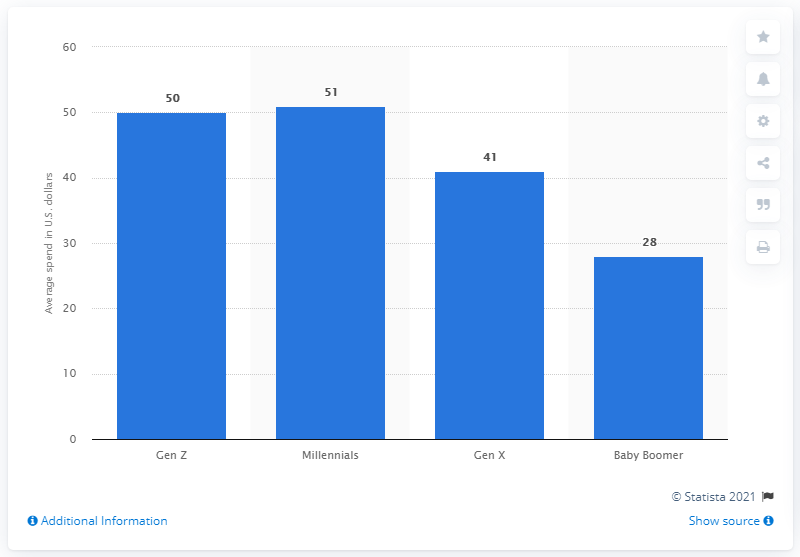Identify some key points in this picture. Gen Z plans to spend an average of 50 dollars during the holiday season. Millennials plan to spend an average of $51 on their pets during the holiday season, according to a survey. 